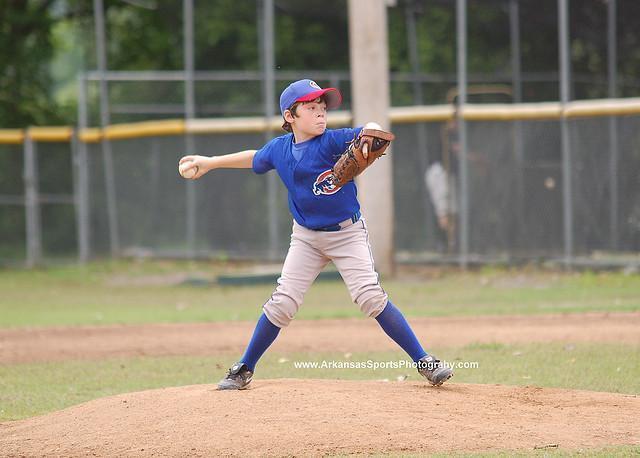Where does the URL text actually exist?
Choose the correct response, then elucidate: 'Answer: answer
Rationale: rationale.'
Options: On boy, on grass, on shoe, image file. Answer: image file.
Rationale: The url indicates the image file. 